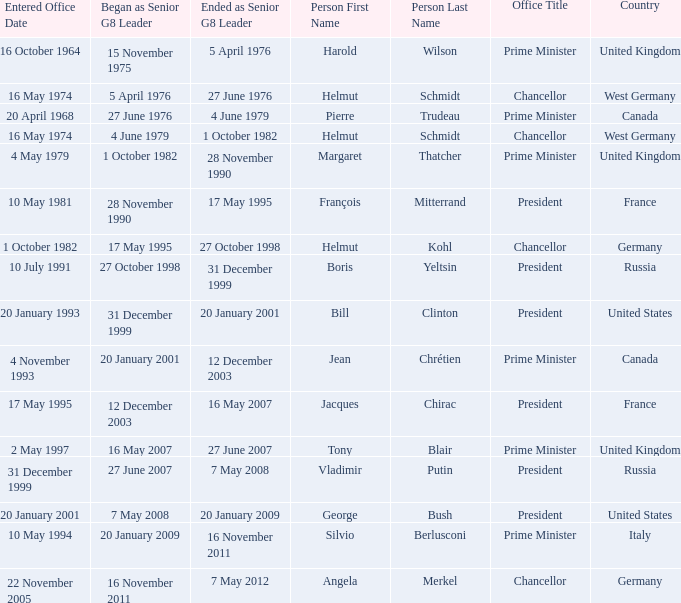When did the Prime Minister of Italy take office? 10 May 1994. 